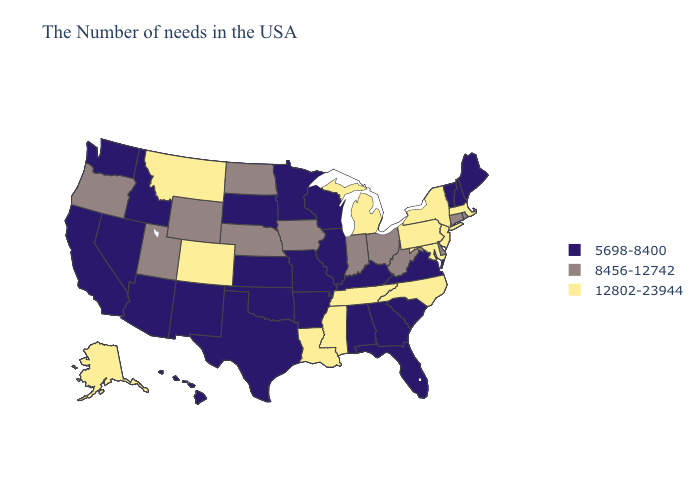Name the states that have a value in the range 8456-12742?
Answer briefly. Rhode Island, Connecticut, Delaware, West Virginia, Ohio, Indiana, Iowa, Nebraska, North Dakota, Wyoming, Utah, Oregon. Which states hav the highest value in the Northeast?
Write a very short answer. Massachusetts, New York, New Jersey, Pennsylvania. Name the states that have a value in the range 8456-12742?
Answer briefly. Rhode Island, Connecticut, Delaware, West Virginia, Ohio, Indiana, Iowa, Nebraska, North Dakota, Wyoming, Utah, Oregon. Does Ohio have the highest value in the MidWest?
Keep it brief. No. What is the value of Arkansas?
Concise answer only. 5698-8400. Which states have the highest value in the USA?
Concise answer only. Massachusetts, New York, New Jersey, Maryland, Pennsylvania, North Carolina, Michigan, Tennessee, Mississippi, Louisiana, Colorado, Montana, Alaska. Name the states that have a value in the range 8456-12742?
Keep it brief. Rhode Island, Connecticut, Delaware, West Virginia, Ohio, Indiana, Iowa, Nebraska, North Dakota, Wyoming, Utah, Oregon. What is the lowest value in states that border Oklahoma?
Give a very brief answer. 5698-8400. Name the states that have a value in the range 12802-23944?
Answer briefly. Massachusetts, New York, New Jersey, Maryland, Pennsylvania, North Carolina, Michigan, Tennessee, Mississippi, Louisiana, Colorado, Montana, Alaska. Name the states that have a value in the range 8456-12742?
Quick response, please. Rhode Island, Connecticut, Delaware, West Virginia, Ohio, Indiana, Iowa, Nebraska, North Dakota, Wyoming, Utah, Oregon. What is the value of Nebraska?
Give a very brief answer. 8456-12742. Name the states that have a value in the range 5698-8400?
Short answer required. Maine, New Hampshire, Vermont, Virginia, South Carolina, Florida, Georgia, Kentucky, Alabama, Wisconsin, Illinois, Missouri, Arkansas, Minnesota, Kansas, Oklahoma, Texas, South Dakota, New Mexico, Arizona, Idaho, Nevada, California, Washington, Hawaii. Among the states that border Utah , which have the lowest value?
Keep it brief. New Mexico, Arizona, Idaho, Nevada. Which states hav the highest value in the South?
Quick response, please. Maryland, North Carolina, Tennessee, Mississippi, Louisiana. What is the value of North Dakota?
Answer briefly. 8456-12742. 